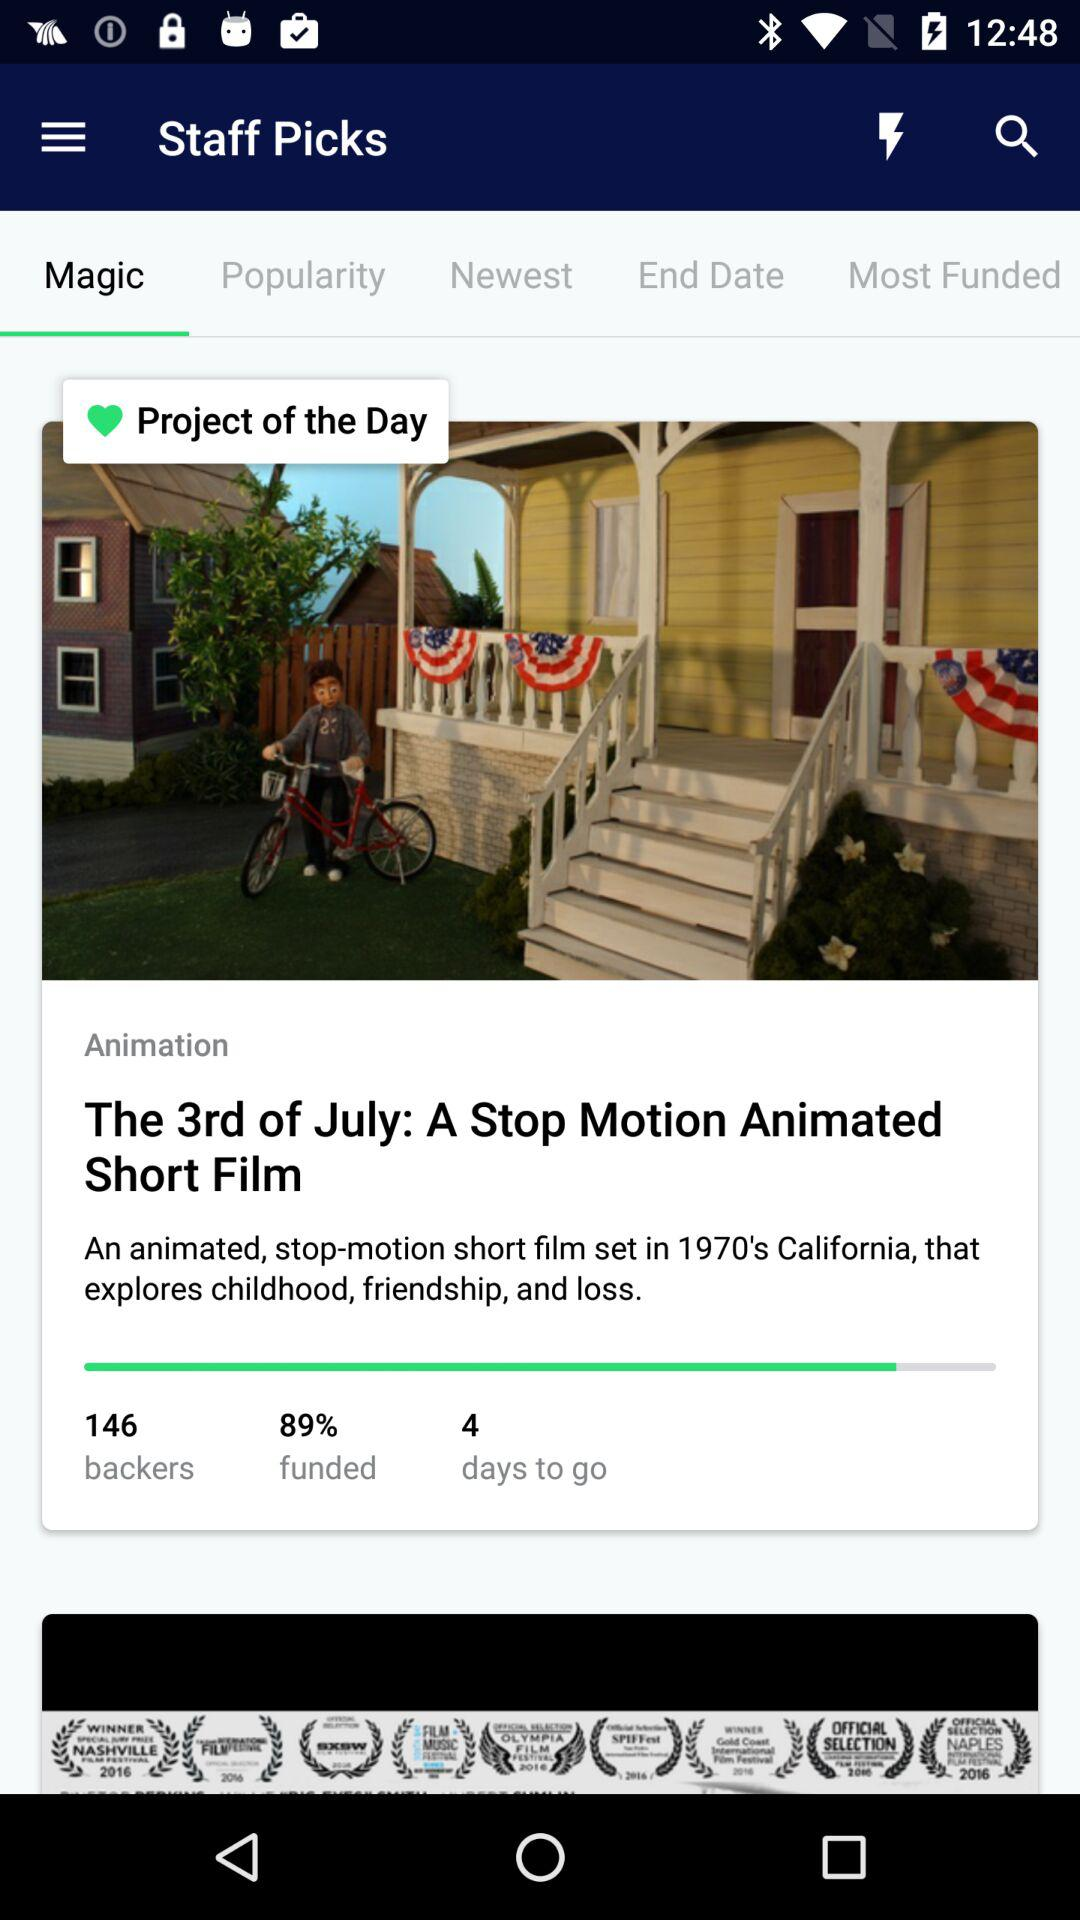What is the number of backers? The number of backers is 146. 